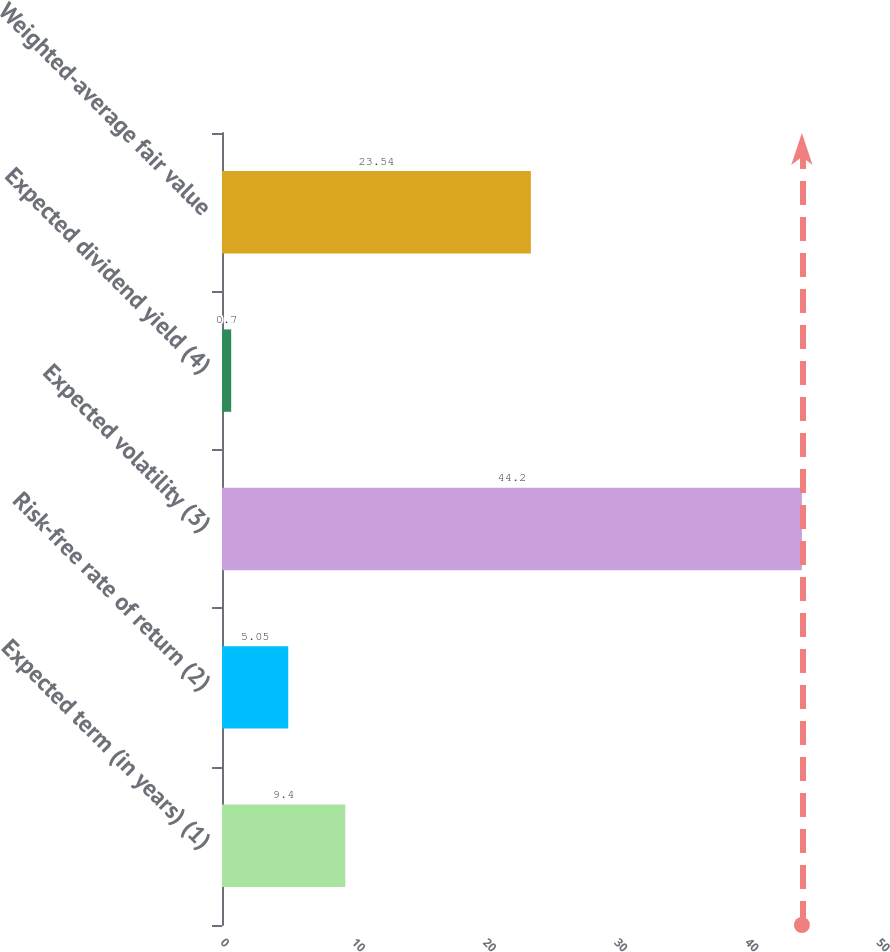<chart> <loc_0><loc_0><loc_500><loc_500><bar_chart><fcel>Expected term (in years) (1)<fcel>Risk-free rate of return (2)<fcel>Expected volatility (3)<fcel>Expected dividend yield (4)<fcel>Weighted-average fair value<nl><fcel>9.4<fcel>5.05<fcel>44.2<fcel>0.7<fcel>23.54<nl></chart> 